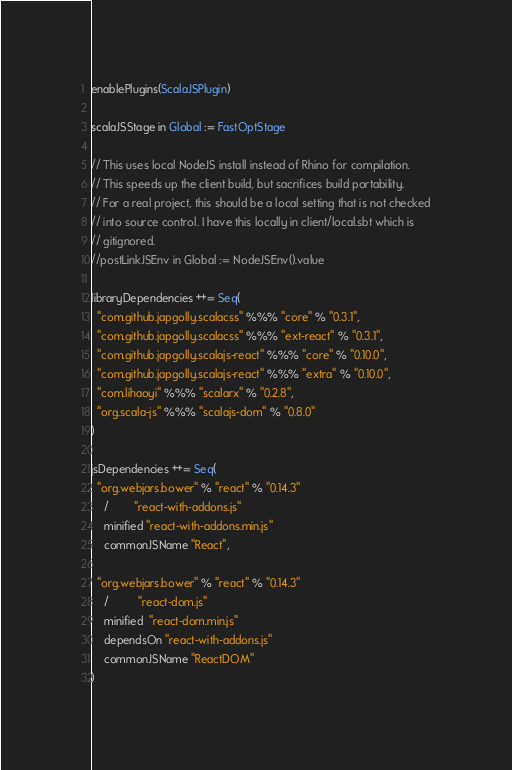Convert code to text. <code><loc_0><loc_0><loc_500><loc_500><_Scala_>enablePlugins(ScalaJSPlugin)

scalaJSStage in Global := FastOptStage

// This uses local NodeJS install instead of Rhino for compilation.
// This speeds up the client build, but sacrifices build portability.
// For a real project, this should be a local setting that is not checked
// into source control. I have this locally in client/local.sbt which is
// gitignored.
//postLinkJSEnv in Global := NodeJSEnv().value

libraryDependencies ++= Seq(
  "com.github.japgolly.scalacss" %%% "core" % "0.3.1",
  "com.github.japgolly.scalacss" %%% "ext-react" % "0.3.1",
  "com.github.japgolly.scalajs-react" %%% "core" % "0.10.0",
  "com.github.japgolly.scalajs-react" %%% "extra" % "0.10.0",
  "com.lihaoyi" %%% "scalarx" % "0.2.8",
  "org.scala-js" %%% "scalajs-dom" % "0.8.0"
)

jsDependencies ++= Seq(
  "org.webjars.bower" % "react" % "0.14.3"
    /        "react-with-addons.js"
    minified "react-with-addons.min.js"
    commonJSName "React",

  "org.webjars.bower" % "react" % "0.14.3"
    /         "react-dom.js"
    minified  "react-dom.min.js"
    dependsOn "react-with-addons.js"
    commonJSName "ReactDOM"
)
</code> 